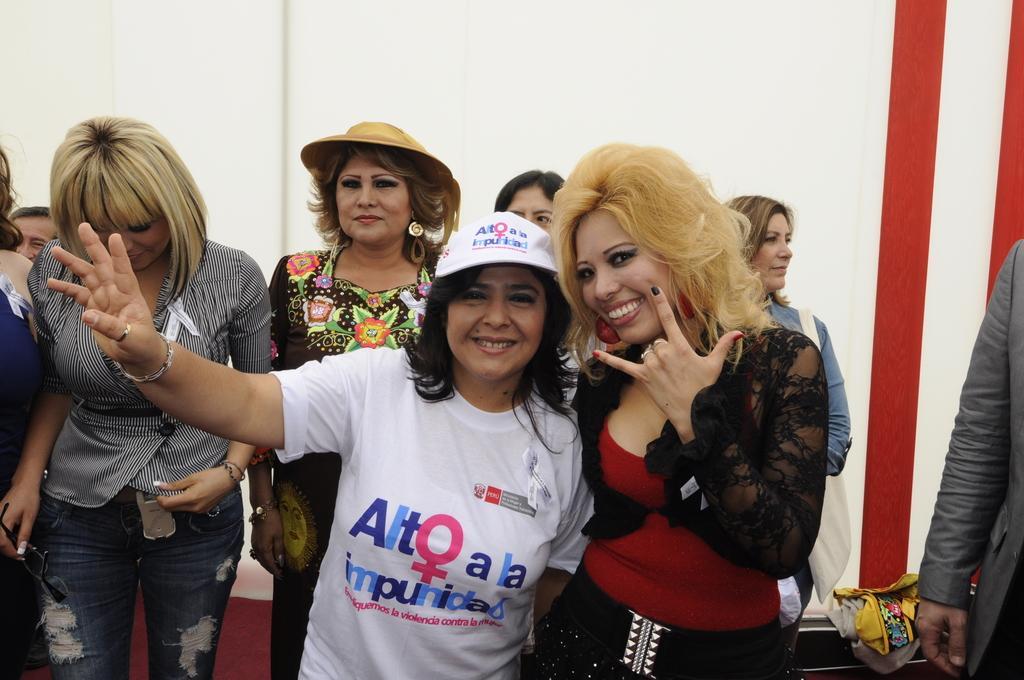In one or two sentences, can you explain what this image depicts? In the center of the image there are ladies standing. In the background of the image there is a wall. To the right side of the image there is a person wearing a suit. 